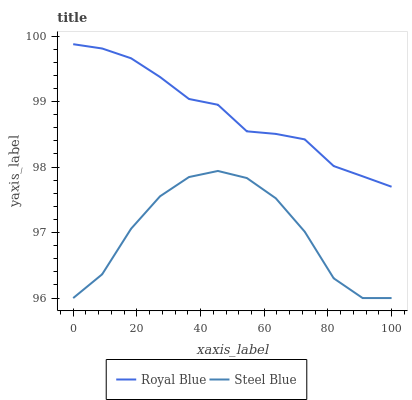Does Steel Blue have the minimum area under the curve?
Answer yes or no. Yes. Does Royal Blue have the maximum area under the curve?
Answer yes or no. Yes. Does Steel Blue have the maximum area under the curve?
Answer yes or no. No. Is Royal Blue the smoothest?
Answer yes or no. Yes. Is Steel Blue the roughest?
Answer yes or no. Yes. Is Steel Blue the smoothest?
Answer yes or no. No. Does Steel Blue have the lowest value?
Answer yes or no. Yes. Does Royal Blue have the highest value?
Answer yes or no. Yes. Does Steel Blue have the highest value?
Answer yes or no. No. Is Steel Blue less than Royal Blue?
Answer yes or no. Yes. Is Royal Blue greater than Steel Blue?
Answer yes or no. Yes. Does Steel Blue intersect Royal Blue?
Answer yes or no. No. 